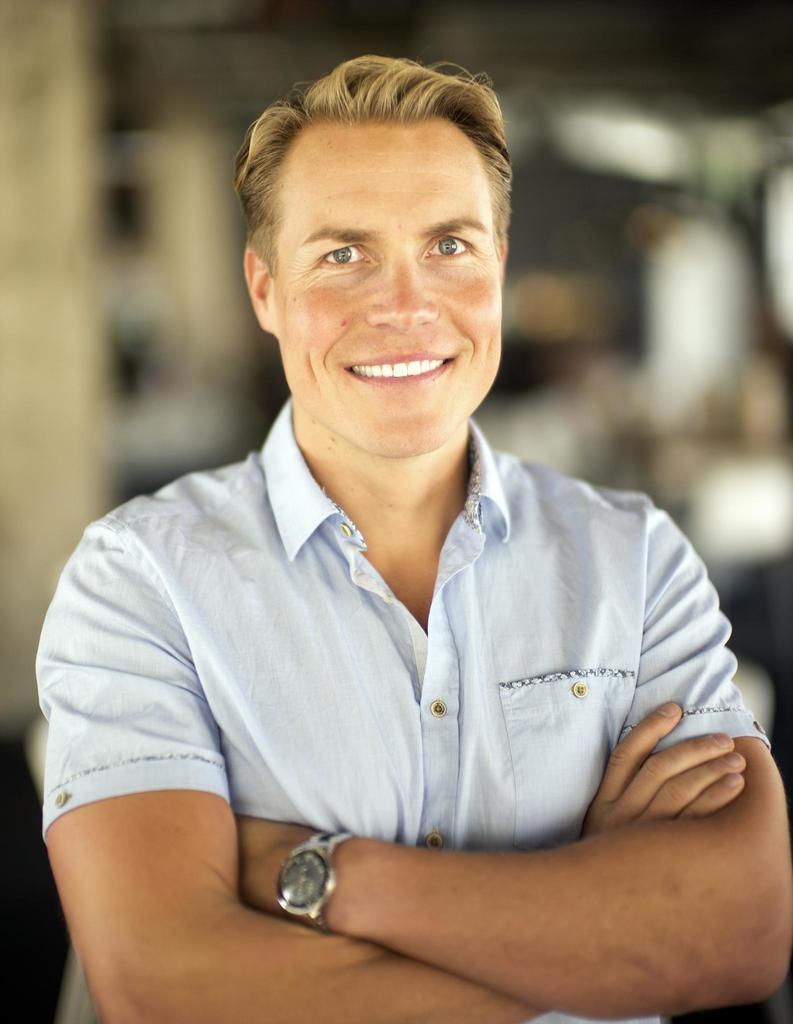Can you describe this image briefly? This picture shows a man standing with a smile on his face and he wore light blue shirt. 